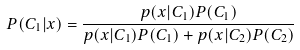Convert formula to latex. <formula><loc_0><loc_0><loc_500><loc_500>P ( C _ { 1 } | x ) = \frac { p ( x | C _ { 1 } ) P ( C _ { 1 } ) } { p ( x | C _ { 1 } ) P ( C _ { 1 } ) + p ( x | C _ { 2 } ) P ( C _ { 2 } ) }</formula> 